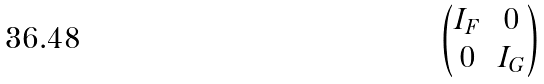<formula> <loc_0><loc_0><loc_500><loc_500>\begin{pmatrix} I _ { F } & 0 \\ 0 & I _ { G } \end{pmatrix}</formula> 